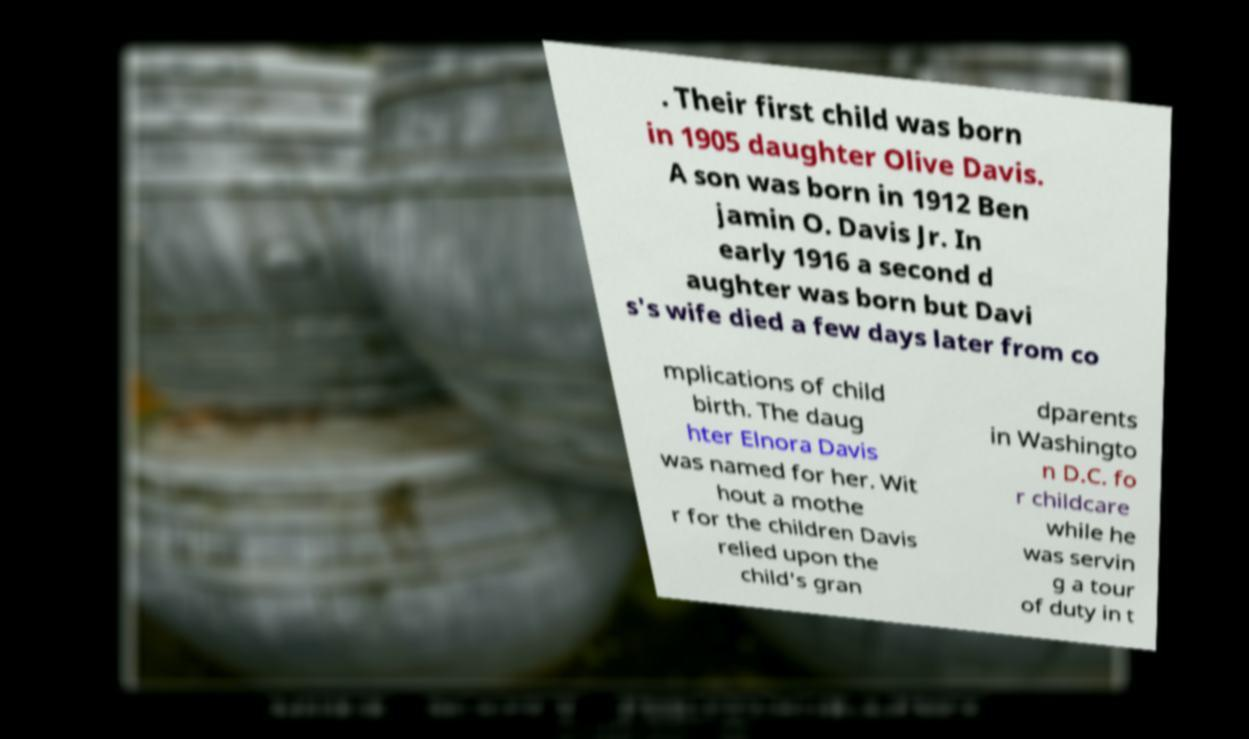Can you read and provide the text displayed in the image?This photo seems to have some interesting text. Can you extract and type it out for me? . Their first child was born in 1905 daughter Olive Davis. A son was born in 1912 Ben jamin O. Davis Jr. In early 1916 a second d aughter was born but Davi s's wife died a few days later from co mplications of child birth. The daug hter Elnora Davis was named for her. Wit hout a mothe r for the children Davis relied upon the child's gran dparents in Washingto n D.C. fo r childcare while he was servin g a tour of duty in t 